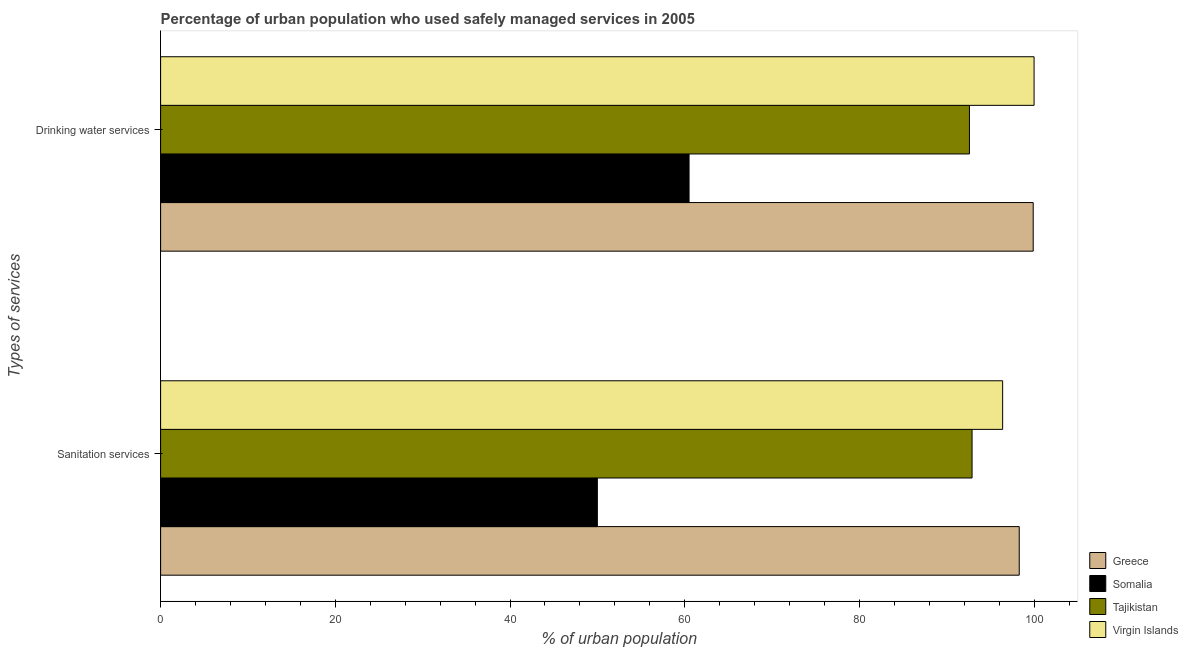How many different coloured bars are there?
Your response must be concise. 4. Are the number of bars per tick equal to the number of legend labels?
Offer a terse response. Yes. How many bars are there on the 2nd tick from the bottom?
Ensure brevity in your answer.  4. What is the label of the 2nd group of bars from the top?
Your response must be concise. Sanitation services. What is the percentage of urban population who used sanitation services in Virgin Islands?
Offer a terse response. 96.4. Across all countries, what is the maximum percentage of urban population who used drinking water services?
Your response must be concise. 100. Across all countries, what is the minimum percentage of urban population who used drinking water services?
Give a very brief answer. 60.5. In which country was the percentage of urban population who used drinking water services maximum?
Your answer should be very brief. Virgin Islands. In which country was the percentage of urban population who used sanitation services minimum?
Keep it short and to the point. Somalia. What is the total percentage of urban population who used drinking water services in the graph?
Ensure brevity in your answer.  353. What is the difference between the percentage of urban population who used sanitation services in Tajikistan and that in Greece?
Offer a very short reply. -5.4. What is the difference between the percentage of urban population who used sanitation services in Somalia and the percentage of urban population who used drinking water services in Virgin Islands?
Your answer should be compact. -50. What is the average percentage of urban population who used sanitation services per country?
Give a very brief answer. 84.4. What is the difference between the percentage of urban population who used drinking water services and percentage of urban population who used sanitation services in Virgin Islands?
Keep it short and to the point. 3.6. What is the ratio of the percentage of urban population who used drinking water services in Somalia to that in Virgin Islands?
Your answer should be compact. 0.6. Is the percentage of urban population who used sanitation services in Tajikistan less than that in Somalia?
Offer a very short reply. No. What does the 1st bar from the top in Drinking water services represents?
Keep it short and to the point. Virgin Islands. What does the 1st bar from the bottom in Sanitation services represents?
Offer a very short reply. Greece. How many bars are there?
Offer a very short reply. 8. Are all the bars in the graph horizontal?
Provide a succinct answer. Yes. Are the values on the major ticks of X-axis written in scientific E-notation?
Your answer should be very brief. No. Does the graph contain any zero values?
Make the answer very short. No. Does the graph contain grids?
Keep it short and to the point. No. Where does the legend appear in the graph?
Your answer should be very brief. Bottom right. How are the legend labels stacked?
Provide a succinct answer. Vertical. What is the title of the graph?
Give a very brief answer. Percentage of urban population who used safely managed services in 2005. What is the label or title of the X-axis?
Ensure brevity in your answer.  % of urban population. What is the label or title of the Y-axis?
Provide a short and direct response. Types of services. What is the % of urban population in Greece in Sanitation services?
Offer a terse response. 98.3. What is the % of urban population of Somalia in Sanitation services?
Your answer should be compact. 50. What is the % of urban population of Tajikistan in Sanitation services?
Offer a terse response. 92.9. What is the % of urban population of Virgin Islands in Sanitation services?
Provide a short and direct response. 96.4. What is the % of urban population of Greece in Drinking water services?
Offer a very short reply. 99.9. What is the % of urban population of Somalia in Drinking water services?
Provide a short and direct response. 60.5. What is the % of urban population of Tajikistan in Drinking water services?
Ensure brevity in your answer.  92.6. What is the % of urban population in Virgin Islands in Drinking water services?
Give a very brief answer. 100. Across all Types of services, what is the maximum % of urban population of Greece?
Your response must be concise. 99.9. Across all Types of services, what is the maximum % of urban population in Somalia?
Offer a very short reply. 60.5. Across all Types of services, what is the maximum % of urban population of Tajikistan?
Provide a succinct answer. 92.9. Across all Types of services, what is the maximum % of urban population in Virgin Islands?
Your answer should be compact. 100. Across all Types of services, what is the minimum % of urban population of Greece?
Provide a short and direct response. 98.3. Across all Types of services, what is the minimum % of urban population of Tajikistan?
Your answer should be very brief. 92.6. Across all Types of services, what is the minimum % of urban population in Virgin Islands?
Your answer should be compact. 96.4. What is the total % of urban population in Greece in the graph?
Make the answer very short. 198.2. What is the total % of urban population in Somalia in the graph?
Make the answer very short. 110.5. What is the total % of urban population in Tajikistan in the graph?
Give a very brief answer. 185.5. What is the total % of urban population in Virgin Islands in the graph?
Your response must be concise. 196.4. What is the difference between the % of urban population in Greece in Sanitation services and the % of urban population in Somalia in Drinking water services?
Offer a terse response. 37.8. What is the difference between the % of urban population in Greece in Sanitation services and the % of urban population in Virgin Islands in Drinking water services?
Your response must be concise. -1.7. What is the difference between the % of urban population of Somalia in Sanitation services and the % of urban population of Tajikistan in Drinking water services?
Make the answer very short. -42.6. What is the difference between the % of urban population in Somalia in Sanitation services and the % of urban population in Virgin Islands in Drinking water services?
Make the answer very short. -50. What is the average % of urban population in Greece per Types of services?
Keep it short and to the point. 99.1. What is the average % of urban population in Somalia per Types of services?
Provide a succinct answer. 55.25. What is the average % of urban population of Tajikistan per Types of services?
Your answer should be very brief. 92.75. What is the average % of urban population of Virgin Islands per Types of services?
Ensure brevity in your answer.  98.2. What is the difference between the % of urban population in Greece and % of urban population in Somalia in Sanitation services?
Provide a succinct answer. 48.3. What is the difference between the % of urban population in Somalia and % of urban population in Tajikistan in Sanitation services?
Keep it short and to the point. -42.9. What is the difference between the % of urban population of Somalia and % of urban population of Virgin Islands in Sanitation services?
Keep it short and to the point. -46.4. What is the difference between the % of urban population of Tajikistan and % of urban population of Virgin Islands in Sanitation services?
Give a very brief answer. -3.5. What is the difference between the % of urban population of Greece and % of urban population of Somalia in Drinking water services?
Make the answer very short. 39.4. What is the difference between the % of urban population in Greece and % of urban population in Virgin Islands in Drinking water services?
Ensure brevity in your answer.  -0.1. What is the difference between the % of urban population of Somalia and % of urban population of Tajikistan in Drinking water services?
Your answer should be compact. -32.1. What is the difference between the % of urban population in Somalia and % of urban population in Virgin Islands in Drinking water services?
Make the answer very short. -39.5. What is the difference between the % of urban population of Tajikistan and % of urban population of Virgin Islands in Drinking water services?
Your answer should be very brief. -7.4. What is the ratio of the % of urban population of Somalia in Sanitation services to that in Drinking water services?
Your response must be concise. 0.83. What is the ratio of the % of urban population of Virgin Islands in Sanitation services to that in Drinking water services?
Your answer should be very brief. 0.96. What is the difference between the highest and the second highest % of urban population in Greece?
Make the answer very short. 1.6. What is the difference between the highest and the second highest % of urban population in Somalia?
Your answer should be compact. 10.5. What is the difference between the highest and the second highest % of urban population in Tajikistan?
Offer a very short reply. 0.3. What is the difference between the highest and the lowest % of urban population of Greece?
Keep it short and to the point. 1.6. What is the difference between the highest and the lowest % of urban population in Somalia?
Give a very brief answer. 10.5. What is the difference between the highest and the lowest % of urban population in Tajikistan?
Your response must be concise. 0.3. What is the difference between the highest and the lowest % of urban population of Virgin Islands?
Your response must be concise. 3.6. 